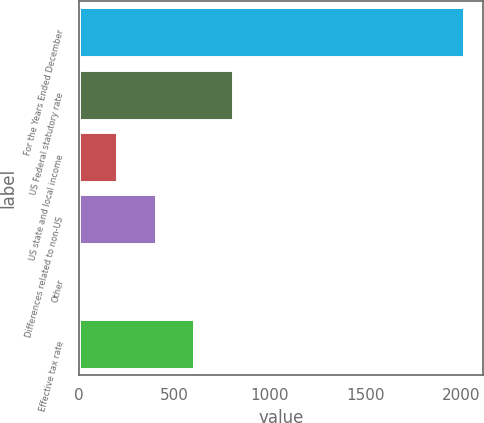Convert chart. <chart><loc_0><loc_0><loc_500><loc_500><bar_chart><fcel>For the Years Ended December<fcel>US Federal statutory rate<fcel>US state and local income<fcel>Differences related to non-US<fcel>Other<fcel>Effective tax rate<nl><fcel>2015<fcel>806.3<fcel>201.95<fcel>403.4<fcel>0.5<fcel>604.85<nl></chart> 